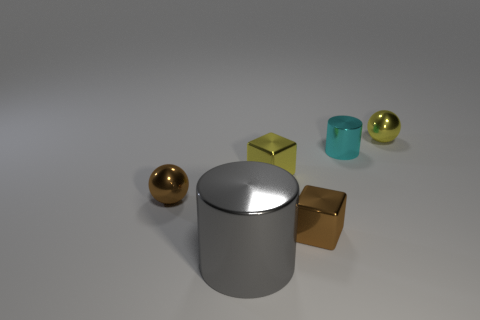There is a cyan object; what shape is it?
Make the answer very short. Cylinder. Are there fewer large metal things in front of the big thing than large gray objects?
Ensure brevity in your answer.  Yes. Are there any tiny yellow objects that have the same shape as the large object?
Offer a very short reply. No. The cyan metallic object that is the same size as the yellow cube is what shape?
Offer a terse response. Cylinder. How many objects are either metallic things or brown cylinders?
Offer a terse response. 6. Are any tiny brown shiny balls visible?
Your answer should be compact. Yes. Are there fewer yellow metal things than yellow matte objects?
Provide a short and direct response. No. Is there a yellow block that has the same size as the yellow ball?
Your answer should be compact. Yes. Do the small cyan object and the large object to the left of the cyan metallic thing have the same shape?
Your answer should be very brief. Yes. What number of cubes are tiny objects or big gray objects?
Give a very brief answer. 2. 